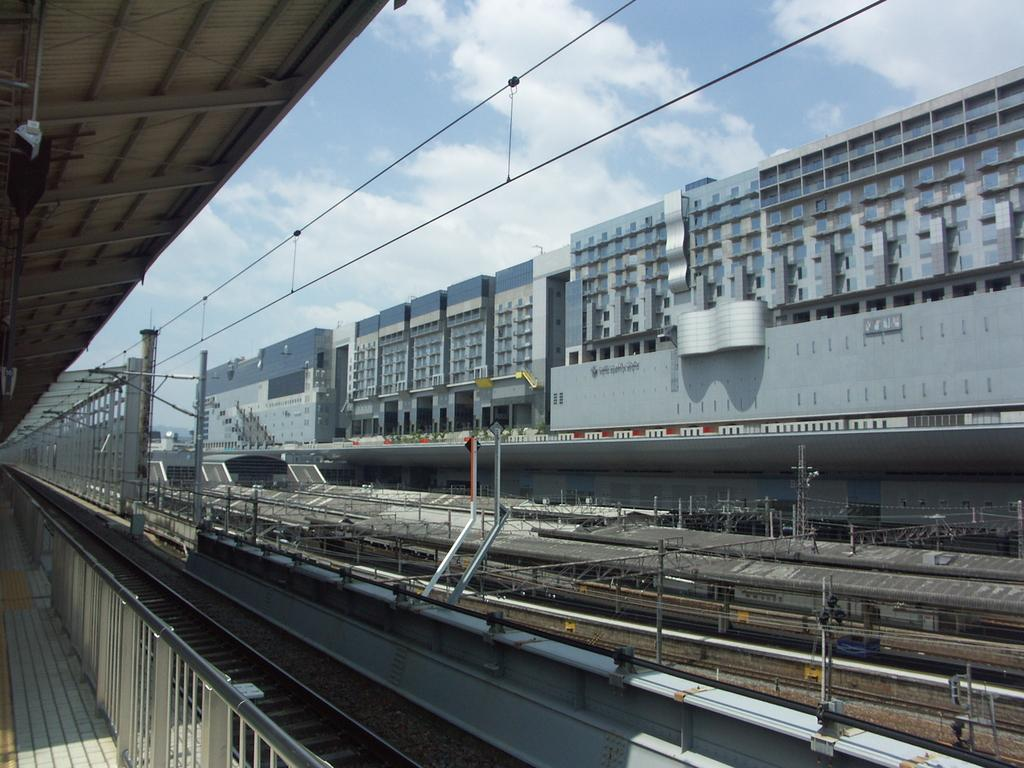What type of transportation infrastructure is visible in the image? There are railway tracks in the image. What else can be seen near the railway tracks? Electric poles are present near the railway tracks. Are there any safety features visible in the image? Yes, there are railings in the image. What can be seen in the background of the image? There are many buildings in the background of the image. What is visible in the sky in the image? The sky is visible in the image, and clouds are present in the sky. What type of cup is being used by the judge in the image? There is no judge or cup present in the image. How does the umbrella help protect people from the rain in the image? There is no umbrella present in the image. 